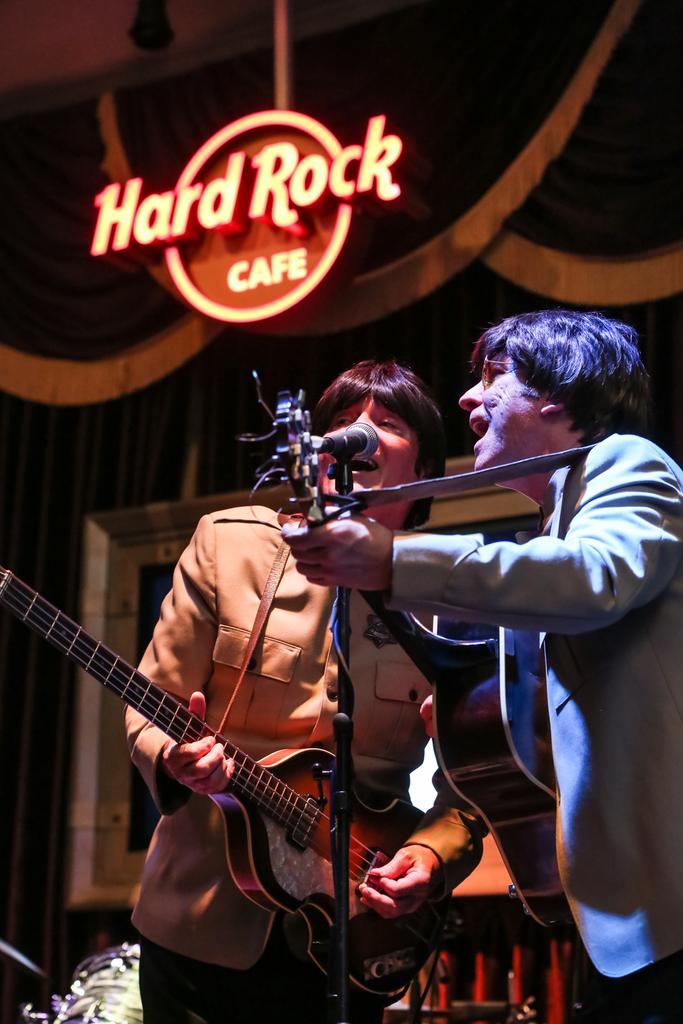How many people are in the image? There are two people in the image. What are the people doing in the image? Both people are singing. What instrument is the person on the left holding? The person on the left is holding a guitar. What can be seen written at the back in the image? The words "Hard Rock Cafe" are written at the back in the image. What type of finger food is being served in the image? There is no finger food present in the image. How many eggs are visible in the image? There are no eggs visible in the image. 